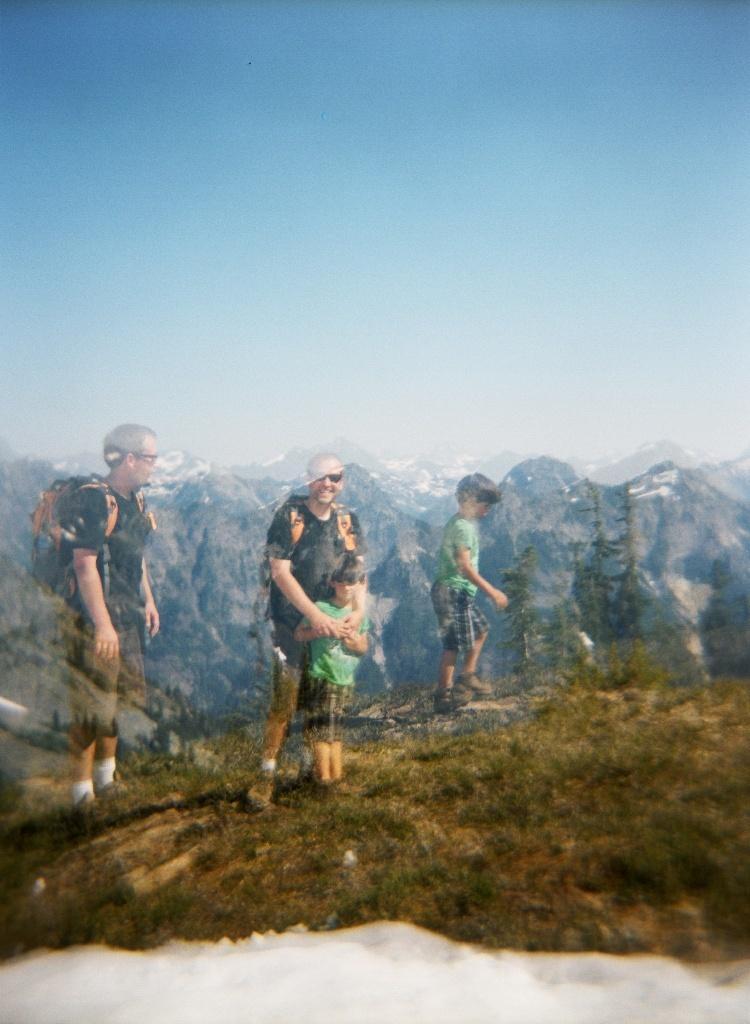How would you summarize this image in a sentence or two? In this picture I can observe four members. Two of them are men wearing black color T shirts and spectacles. Two of them are children. All of them are standing on the land. In the background there are some hills and trees. I can observe a sky. 